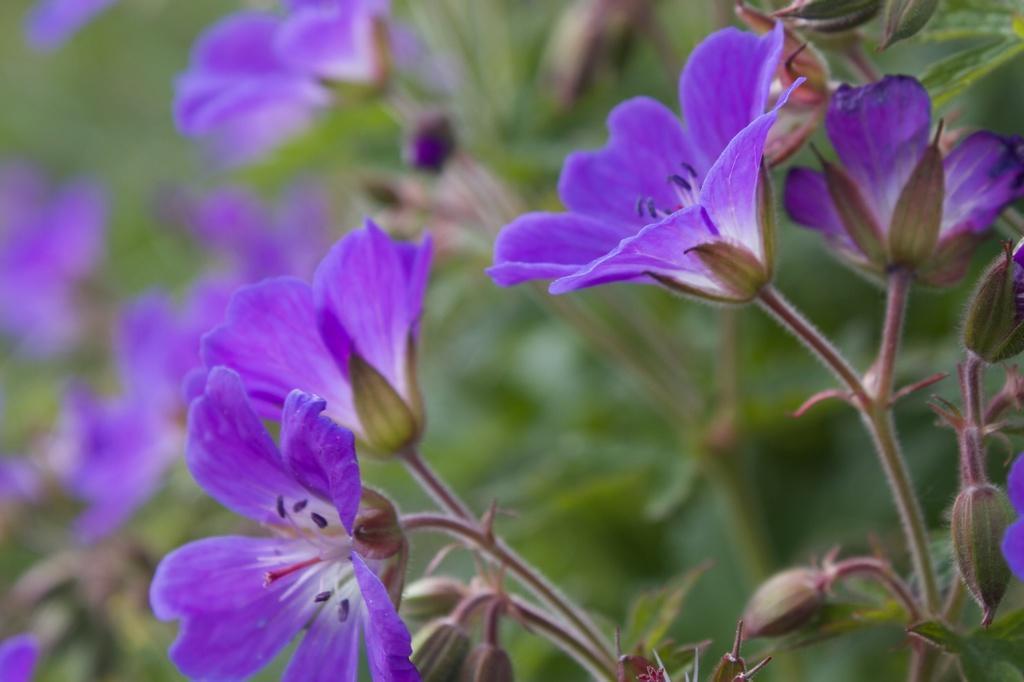In one or two sentences, can you explain what this image depicts? The picture consists of flowers and plants. The background is blurred. 